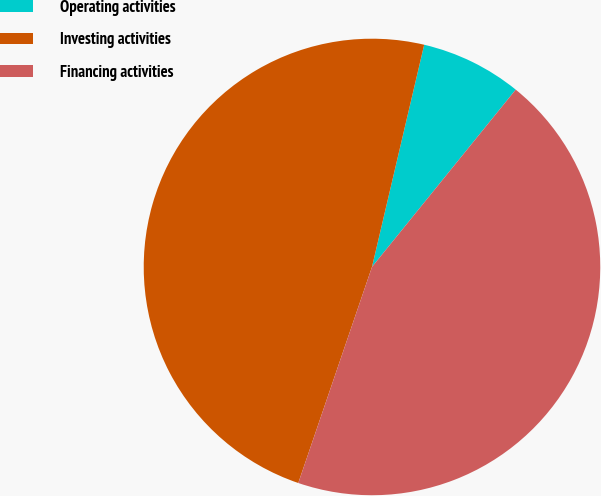Convert chart. <chart><loc_0><loc_0><loc_500><loc_500><pie_chart><fcel>Operating activities<fcel>Investing activities<fcel>Financing activities<nl><fcel>7.17%<fcel>48.44%<fcel>44.39%<nl></chart> 